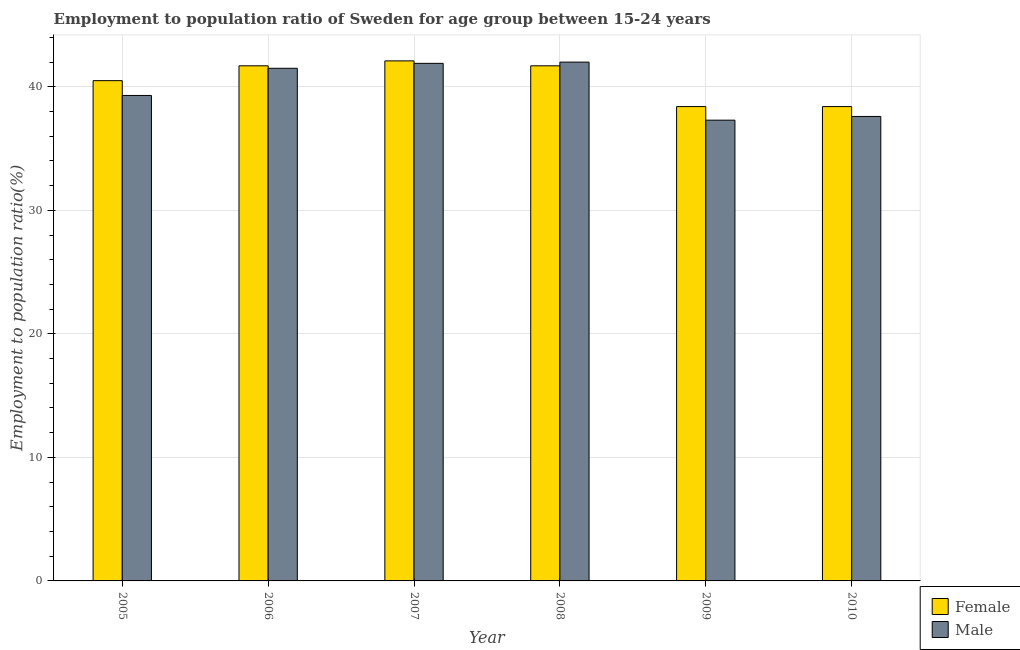How many different coloured bars are there?
Your answer should be very brief. 2. How many groups of bars are there?
Your response must be concise. 6. Are the number of bars on each tick of the X-axis equal?
Offer a very short reply. Yes. How many bars are there on the 2nd tick from the right?
Provide a short and direct response. 2. What is the label of the 2nd group of bars from the left?
Offer a very short reply. 2006. In how many cases, is the number of bars for a given year not equal to the number of legend labels?
Your answer should be very brief. 0. What is the employment to population ratio(female) in 2009?
Offer a very short reply. 38.4. Across all years, what is the maximum employment to population ratio(female)?
Provide a short and direct response. 42.1. Across all years, what is the minimum employment to population ratio(male)?
Give a very brief answer. 37.3. In which year was the employment to population ratio(male) maximum?
Provide a short and direct response. 2008. In which year was the employment to population ratio(female) minimum?
Ensure brevity in your answer.  2009. What is the total employment to population ratio(female) in the graph?
Offer a very short reply. 242.8. What is the difference between the employment to population ratio(male) in 2007 and that in 2010?
Your answer should be compact. 4.3. What is the difference between the employment to population ratio(male) in 2010 and the employment to population ratio(female) in 2006?
Keep it short and to the point. -3.9. What is the average employment to population ratio(female) per year?
Your answer should be compact. 40.47. What is the ratio of the employment to population ratio(male) in 2006 to that in 2009?
Provide a succinct answer. 1.11. Is the difference between the employment to population ratio(female) in 2006 and 2008 greater than the difference between the employment to population ratio(male) in 2006 and 2008?
Provide a succinct answer. No. What is the difference between the highest and the second highest employment to population ratio(female)?
Your answer should be very brief. 0.4. What is the difference between the highest and the lowest employment to population ratio(female)?
Provide a succinct answer. 3.7. Is the sum of the employment to population ratio(male) in 2005 and 2007 greater than the maximum employment to population ratio(female) across all years?
Your answer should be very brief. Yes. What does the 1st bar from the right in 2010 represents?
Provide a succinct answer. Male. Are all the bars in the graph horizontal?
Keep it short and to the point. No. How many years are there in the graph?
Offer a very short reply. 6. Are the values on the major ticks of Y-axis written in scientific E-notation?
Offer a very short reply. No. Does the graph contain any zero values?
Provide a short and direct response. No. Where does the legend appear in the graph?
Give a very brief answer. Bottom right. What is the title of the graph?
Keep it short and to the point. Employment to population ratio of Sweden for age group between 15-24 years. Does "Nitrous oxide emissions" appear as one of the legend labels in the graph?
Your answer should be very brief. No. What is the label or title of the X-axis?
Ensure brevity in your answer.  Year. What is the Employment to population ratio(%) in Female in 2005?
Offer a terse response. 40.5. What is the Employment to population ratio(%) of Male in 2005?
Keep it short and to the point. 39.3. What is the Employment to population ratio(%) in Female in 2006?
Your response must be concise. 41.7. What is the Employment to population ratio(%) of Male in 2006?
Your response must be concise. 41.5. What is the Employment to population ratio(%) of Female in 2007?
Offer a terse response. 42.1. What is the Employment to population ratio(%) of Male in 2007?
Ensure brevity in your answer.  41.9. What is the Employment to population ratio(%) in Female in 2008?
Provide a short and direct response. 41.7. What is the Employment to population ratio(%) in Male in 2008?
Your answer should be compact. 42. What is the Employment to population ratio(%) of Female in 2009?
Ensure brevity in your answer.  38.4. What is the Employment to population ratio(%) in Male in 2009?
Give a very brief answer. 37.3. What is the Employment to population ratio(%) of Female in 2010?
Your answer should be very brief. 38.4. What is the Employment to population ratio(%) in Male in 2010?
Your answer should be very brief. 37.6. Across all years, what is the maximum Employment to population ratio(%) in Female?
Make the answer very short. 42.1. Across all years, what is the maximum Employment to population ratio(%) in Male?
Offer a terse response. 42. Across all years, what is the minimum Employment to population ratio(%) in Female?
Ensure brevity in your answer.  38.4. Across all years, what is the minimum Employment to population ratio(%) of Male?
Your response must be concise. 37.3. What is the total Employment to population ratio(%) in Female in the graph?
Ensure brevity in your answer.  242.8. What is the total Employment to population ratio(%) in Male in the graph?
Provide a succinct answer. 239.6. What is the difference between the Employment to population ratio(%) of Female in 2005 and that in 2007?
Your response must be concise. -1.6. What is the difference between the Employment to population ratio(%) of Male in 2005 and that in 2007?
Provide a short and direct response. -2.6. What is the difference between the Employment to population ratio(%) in Female in 2005 and that in 2008?
Make the answer very short. -1.2. What is the difference between the Employment to population ratio(%) in Female in 2005 and that in 2009?
Keep it short and to the point. 2.1. What is the difference between the Employment to population ratio(%) of Male in 2005 and that in 2009?
Offer a terse response. 2. What is the difference between the Employment to population ratio(%) of Female in 2005 and that in 2010?
Provide a succinct answer. 2.1. What is the difference between the Employment to population ratio(%) of Female in 2006 and that in 2008?
Provide a succinct answer. 0. What is the difference between the Employment to population ratio(%) in Male in 2006 and that in 2008?
Your answer should be compact. -0.5. What is the difference between the Employment to population ratio(%) in Female in 2006 and that in 2009?
Ensure brevity in your answer.  3.3. What is the difference between the Employment to population ratio(%) in Female in 2006 and that in 2010?
Keep it short and to the point. 3.3. What is the difference between the Employment to population ratio(%) in Female in 2007 and that in 2008?
Make the answer very short. 0.4. What is the difference between the Employment to population ratio(%) of Male in 2007 and that in 2009?
Keep it short and to the point. 4.6. What is the difference between the Employment to population ratio(%) of Female in 2008 and that in 2009?
Your answer should be very brief. 3.3. What is the difference between the Employment to population ratio(%) of Male in 2008 and that in 2009?
Provide a short and direct response. 4.7. What is the difference between the Employment to population ratio(%) of Female in 2008 and that in 2010?
Your response must be concise. 3.3. What is the difference between the Employment to population ratio(%) of Male in 2008 and that in 2010?
Your answer should be very brief. 4.4. What is the difference between the Employment to population ratio(%) of Male in 2009 and that in 2010?
Your answer should be compact. -0.3. What is the difference between the Employment to population ratio(%) in Female in 2005 and the Employment to population ratio(%) in Male in 2006?
Your response must be concise. -1. What is the difference between the Employment to population ratio(%) of Female in 2006 and the Employment to population ratio(%) of Male in 2007?
Make the answer very short. -0.2. What is the difference between the Employment to population ratio(%) of Female in 2006 and the Employment to population ratio(%) of Male in 2009?
Keep it short and to the point. 4.4. What is the difference between the Employment to population ratio(%) of Female in 2006 and the Employment to population ratio(%) of Male in 2010?
Your answer should be compact. 4.1. What is the difference between the Employment to population ratio(%) of Female in 2007 and the Employment to population ratio(%) of Male in 2010?
Give a very brief answer. 4.5. What is the difference between the Employment to population ratio(%) in Female in 2008 and the Employment to population ratio(%) in Male in 2009?
Your response must be concise. 4.4. What is the difference between the Employment to population ratio(%) in Female in 2008 and the Employment to population ratio(%) in Male in 2010?
Ensure brevity in your answer.  4.1. What is the average Employment to population ratio(%) of Female per year?
Provide a succinct answer. 40.47. What is the average Employment to population ratio(%) in Male per year?
Your response must be concise. 39.93. In the year 2005, what is the difference between the Employment to population ratio(%) in Female and Employment to population ratio(%) in Male?
Ensure brevity in your answer.  1.2. In the year 2006, what is the difference between the Employment to population ratio(%) in Female and Employment to population ratio(%) in Male?
Offer a very short reply. 0.2. In the year 2009, what is the difference between the Employment to population ratio(%) in Female and Employment to population ratio(%) in Male?
Make the answer very short. 1.1. In the year 2010, what is the difference between the Employment to population ratio(%) of Female and Employment to population ratio(%) of Male?
Keep it short and to the point. 0.8. What is the ratio of the Employment to population ratio(%) in Female in 2005 to that in 2006?
Your response must be concise. 0.97. What is the ratio of the Employment to population ratio(%) in Male in 2005 to that in 2006?
Ensure brevity in your answer.  0.95. What is the ratio of the Employment to population ratio(%) of Female in 2005 to that in 2007?
Ensure brevity in your answer.  0.96. What is the ratio of the Employment to population ratio(%) of Male in 2005 to that in 2007?
Offer a terse response. 0.94. What is the ratio of the Employment to population ratio(%) in Female in 2005 to that in 2008?
Make the answer very short. 0.97. What is the ratio of the Employment to population ratio(%) in Male in 2005 to that in 2008?
Your response must be concise. 0.94. What is the ratio of the Employment to population ratio(%) in Female in 2005 to that in 2009?
Give a very brief answer. 1.05. What is the ratio of the Employment to population ratio(%) in Male in 2005 to that in 2009?
Your answer should be very brief. 1.05. What is the ratio of the Employment to population ratio(%) of Female in 2005 to that in 2010?
Provide a short and direct response. 1.05. What is the ratio of the Employment to population ratio(%) of Male in 2005 to that in 2010?
Keep it short and to the point. 1.05. What is the ratio of the Employment to population ratio(%) in Female in 2006 to that in 2009?
Give a very brief answer. 1.09. What is the ratio of the Employment to population ratio(%) of Male in 2006 to that in 2009?
Offer a terse response. 1.11. What is the ratio of the Employment to population ratio(%) in Female in 2006 to that in 2010?
Keep it short and to the point. 1.09. What is the ratio of the Employment to population ratio(%) of Male in 2006 to that in 2010?
Give a very brief answer. 1.1. What is the ratio of the Employment to population ratio(%) in Female in 2007 to that in 2008?
Make the answer very short. 1.01. What is the ratio of the Employment to population ratio(%) in Female in 2007 to that in 2009?
Your answer should be very brief. 1.1. What is the ratio of the Employment to population ratio(%) in Male in 2007 to that in 2009?
Ensure brevity in your answer.  1.12. What is the ratio of the Employment to population ratio(%) of Female in 2007 to that in 2010?
Offer a terse response. 1.1. What is the ratio of the Employment to population ratio(%) in Male in 2007 to that in 2010?
Keep it short and to the point. 1.11. What is the ratio of the Employment to population ratio(%) in Female in 2008 to that in 2009?
Your response must be concise. 1.09. What is the ratio of the Employment to population ratio(%) in Male in 2008 to that in 2009?
Your answer should be compact. 1.13. What is the ratio of the Employment to population ratio(%) in Female in 2008 to that in 2010?
Provide a succinct answer. 1.09. What is the ratio of the Employment to population ratio(%) of Male in 2008 to that in 2010?
Ensure brevity in your answer.  1.12. What is the difference between the highest and the second highest Employment to population ratio(%) in Female?
Offer a terse response. 0.4. What is the difference between the highest and the second highest Employment to population ratio(%) of Male?
Keep it short and to the point. 0.1. What is the difference between the highest and the lowest Employment to population ratio(%) in Female?
Offer a very short reply. 3.7. 